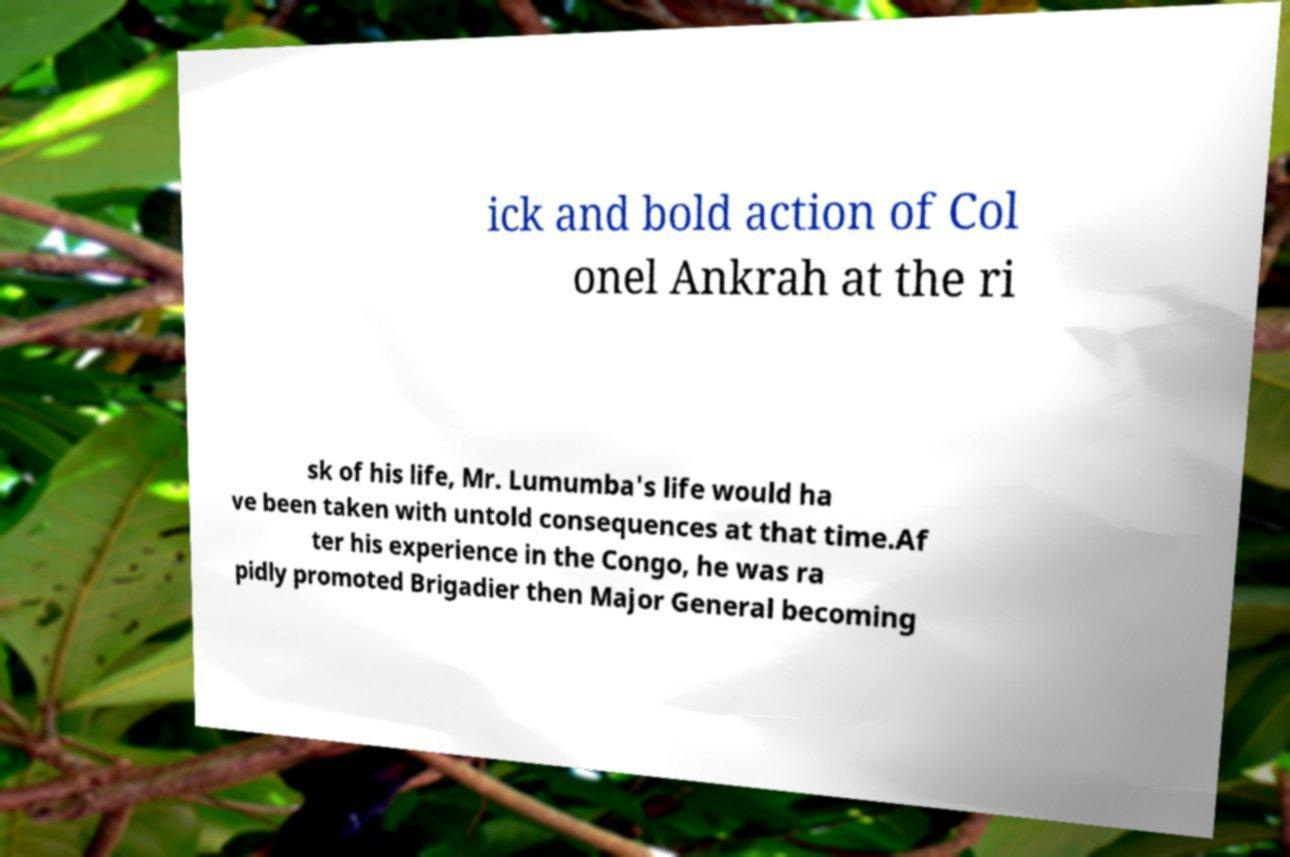Can you accurately transcribe the text from the provided image for me? ick and bold action of Col onel Ankrah at the ri sk of his life, Mr. Lumumba's life would ha ve been taken with untold consequences at that time.Af ter his experience in the Congo, he was ra pidly promoted Brigadier then Major General becoming 